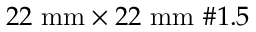<formula> <loc_0><loc_0><loc_500><loc_500>2 2 m m \times 2 2 m m \# 1 . 5</formula> 